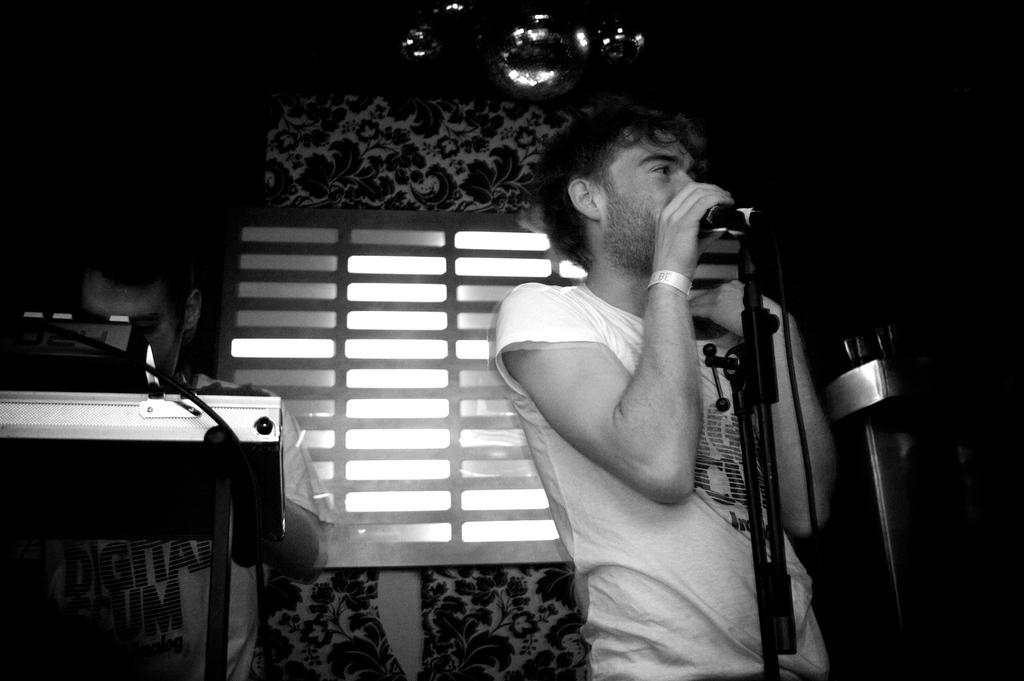What is the main subject of the image? There is a man standing in the image. What is the man doing in the image? The man is singing. What object is the man holding while singing? The man is holding a microphone. Is there anyone else present in the image? Yes, there is another man standing beside the first man. What type of condition is the van experiencing in the image? There is no van present in the image. How many feathers can be seen on the man's hat in the image? The man is not wearing a hat, and therefore there are no feathers present in the image. 